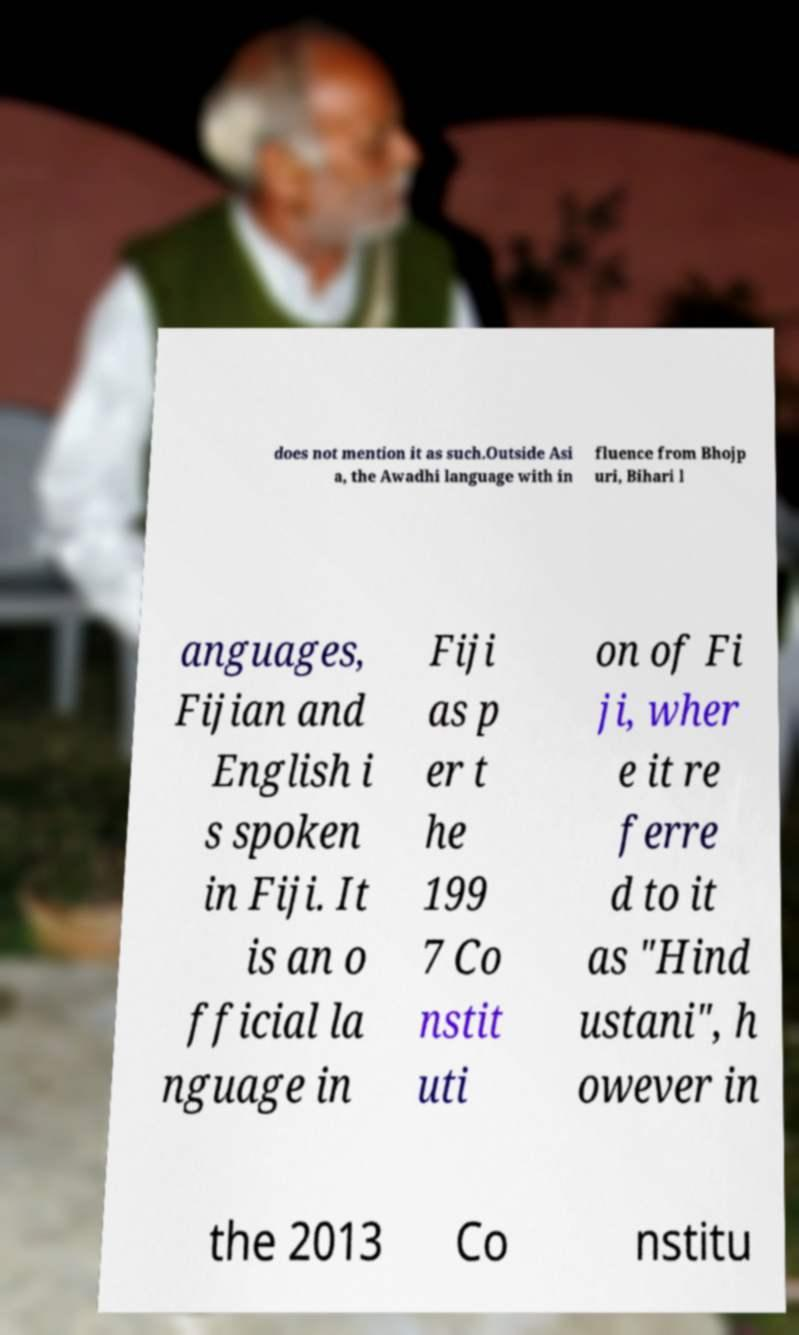Can you read and provide the text displayed in the image?This photo seems to have some interesting text. Can you extract and type it out for me? does not mention it as such.Outside Asi a, the Awadhi language with in fluence from Bhojp uri, Bihari l anguages, Fijian and English i s spoken in Fiji. It is an o fficial la nguage in Fiji as p er t he 199 7 Co nstit uti on of Fi ji, wher e it re ferre d to it as "Hind ustani", h owever in the 2013 Co nstitu 